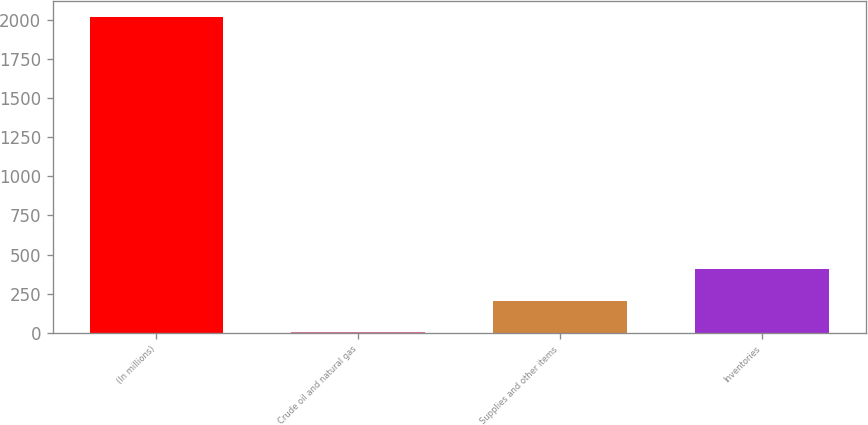Convert chart to OTSL. <chart><loc_0><loc_0><loc_500><loc_500><bar_chart><fcel>(In millions)<fcel>Crude oil and natural gas<fcel>Supplies and other items<fcel>Inventories<nl><fcel>2016<fcel>6<fcel>207<fcel>408<nl></chart> 